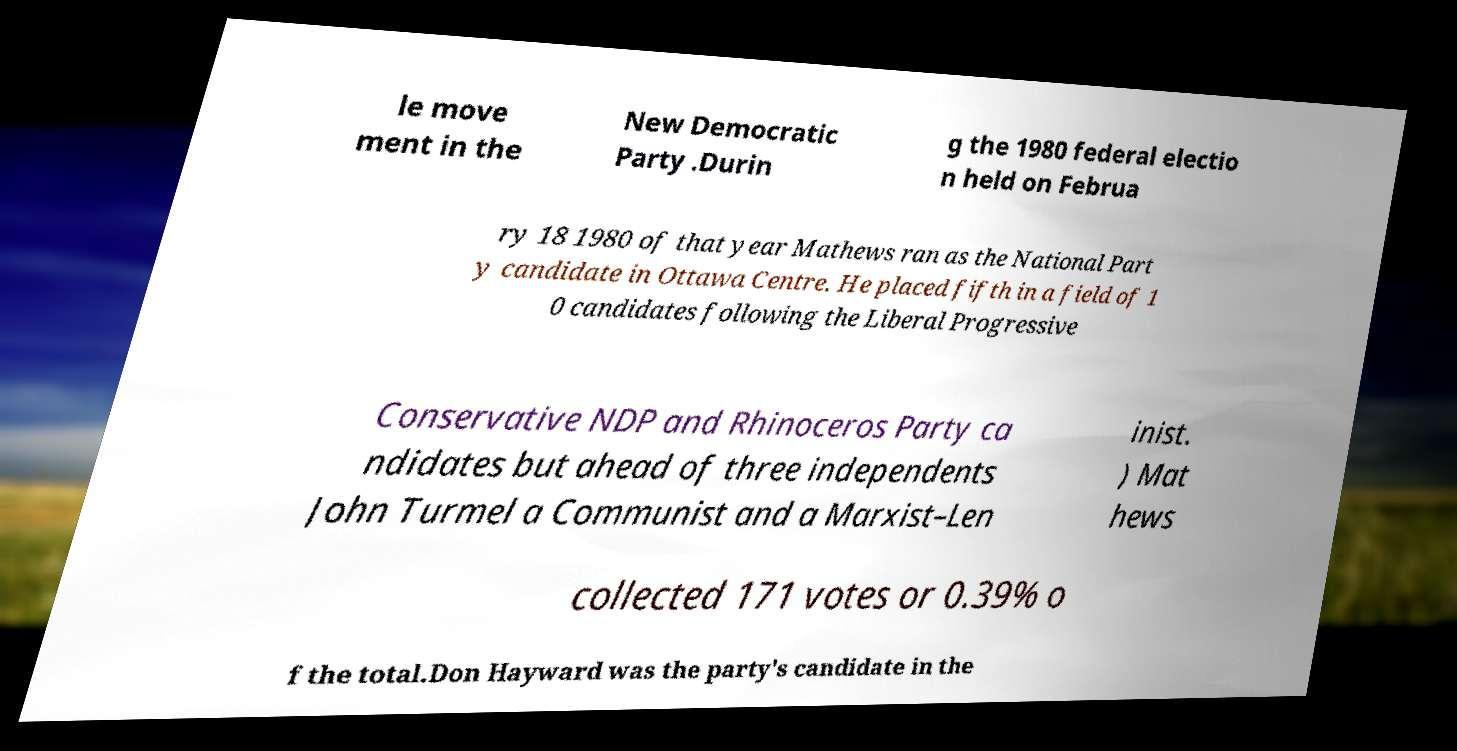Could you assist in decoding the text presented in this image and type it out clearly? le move ment in the New Democratic Party .Durin g the 1980 federal electio n held on Februa ry 18 1980 of that year Mathews ran as the National Part y candidate in Ottawa Centre. He placed fifth in a field of 1 0 candidates following the Liberal Progressive Conservative NDP and Rhinoceros Party ca ndidates but ahead of three independents John Turmel a Communist and a Marxist–Len inist. ) Mat hews collected 171 votes or 0.39% o f the total.Don Hayward was the party's candidate in the 